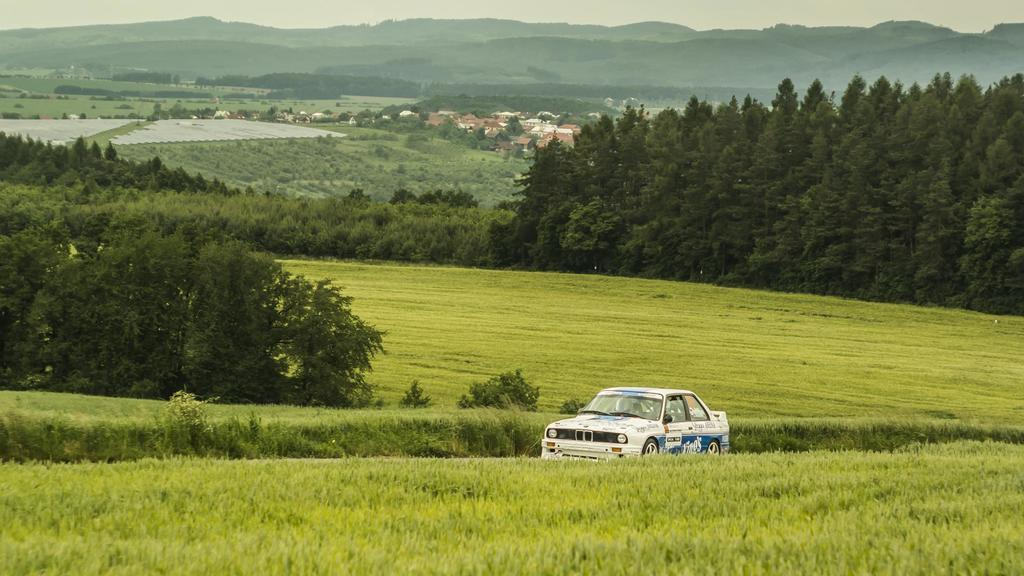What type of vegetation can be seen in the image? There are trees and plants in the image. What is located at the bottom of the image? There is a car at the bottom of the image. What geographical feature is visible at the top of the image? There are hills at the top of the image. What time of day is it in the image, considering the presence of an afternoon hall and bed? There is no mention of an afternoon hall or bed in the image, so it is not possible to determine the time of day. 